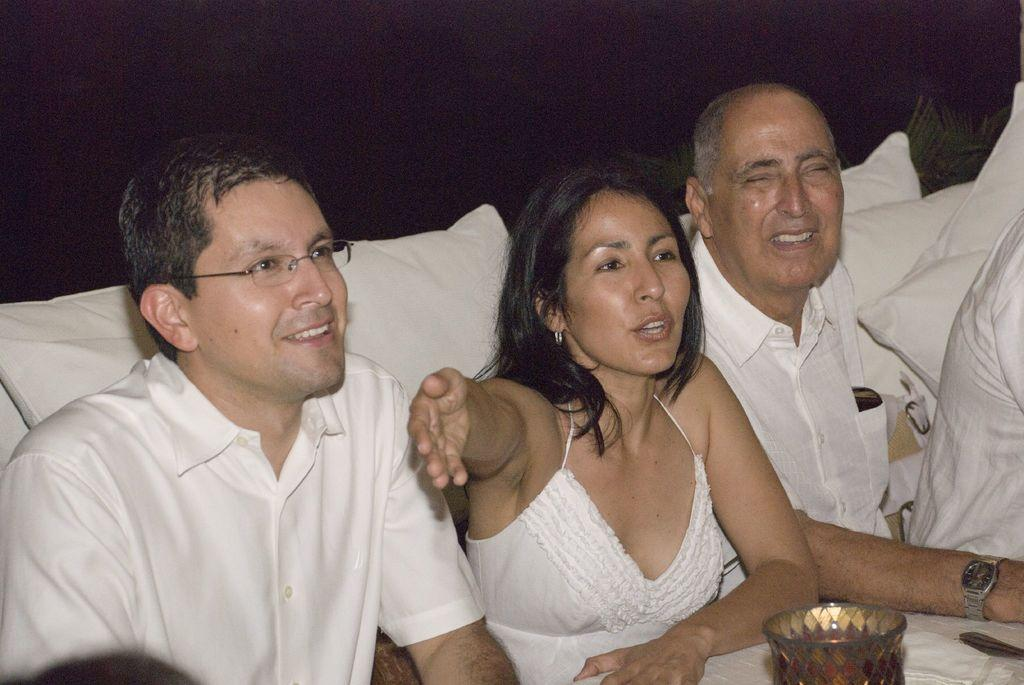How many persons are in the image? There are persons in the image, but the exact number is not specified. What can be seen in the background of the image? There are cushions in the background of the image. What object is located in front of the persons? There is an object that looks like a bowl in front of the persons. What is the color of the background in the image? The background of the image is dark. What type of organization is depicted in the image? There is no organization depicted in the image; it features persons, cushions, and a bowl-like object. Can you tell me how many veins are visible on the persons in the image? There is no information about veins or any other anatomical features of the persons in the image. 